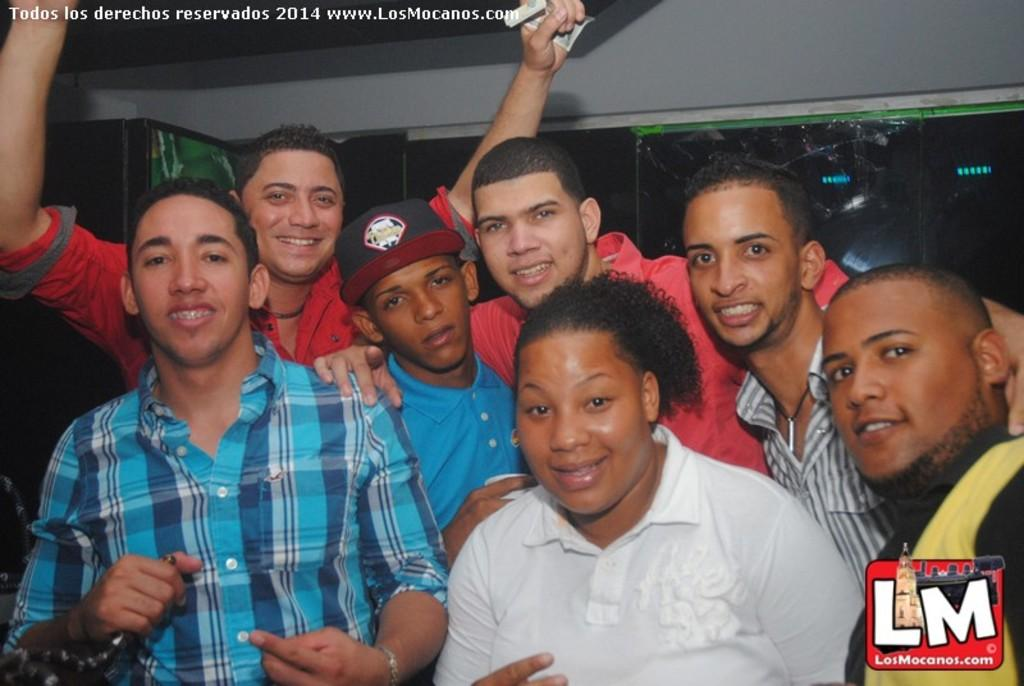How many people are in the image? There are seven persons in the image. What is the facial expression of the people in the image? The persons are smiling. Where can a logo be found in the image? The logo is at the right bottom of the image. What is located at the left top of the image? There is some text at the left top of the image. What type of lipstick is the representative wearing in the image? There is no representative or lipstick present in the image. What trick is being performed by the persons in the image? There is no trick being performed by the persons in the image; they are simply smiling. 